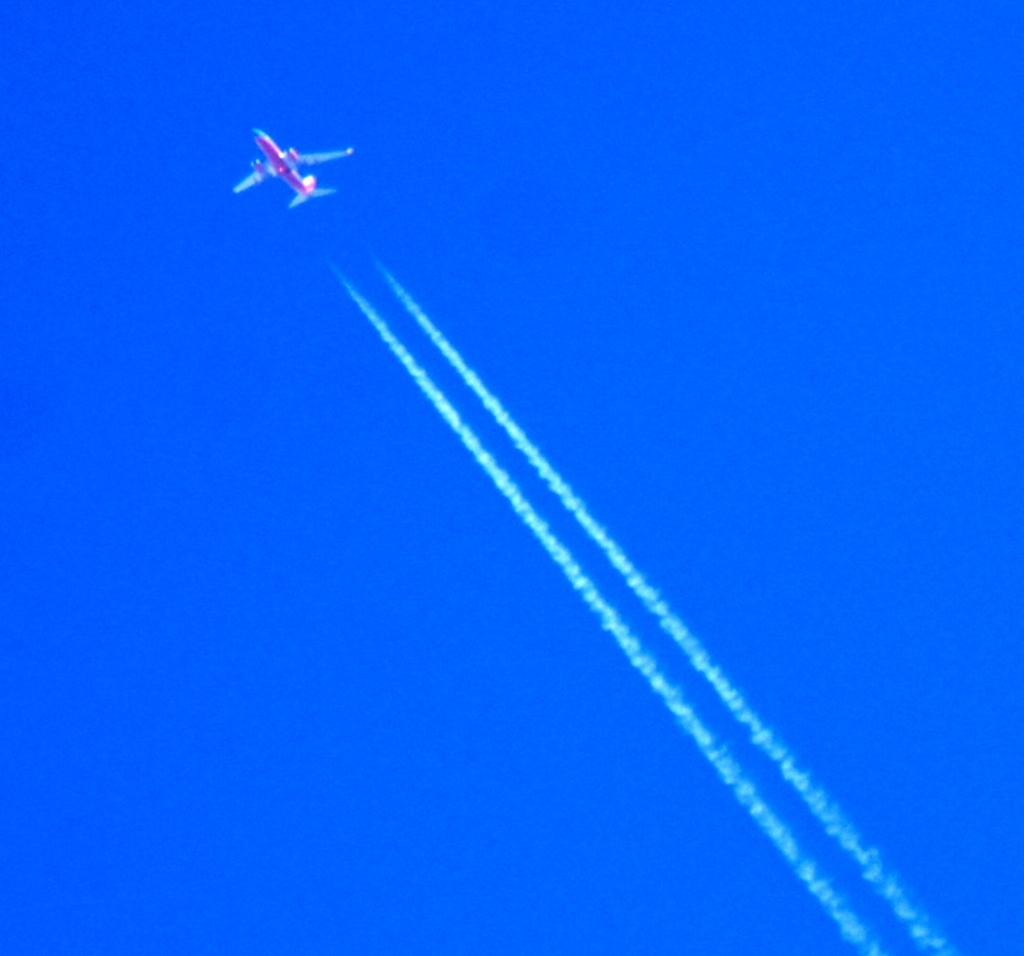What is the main subject of the image? The main subject of the image is an airplane. Where is the airplane located in the image? The airplane is at the top of the image. What else can be seen in the image besides the airplane? There is smoke in the center of the image. What type of lock is used to secure the airplane in the image? There is no lock visible in the image, and the airplane is not secured. 